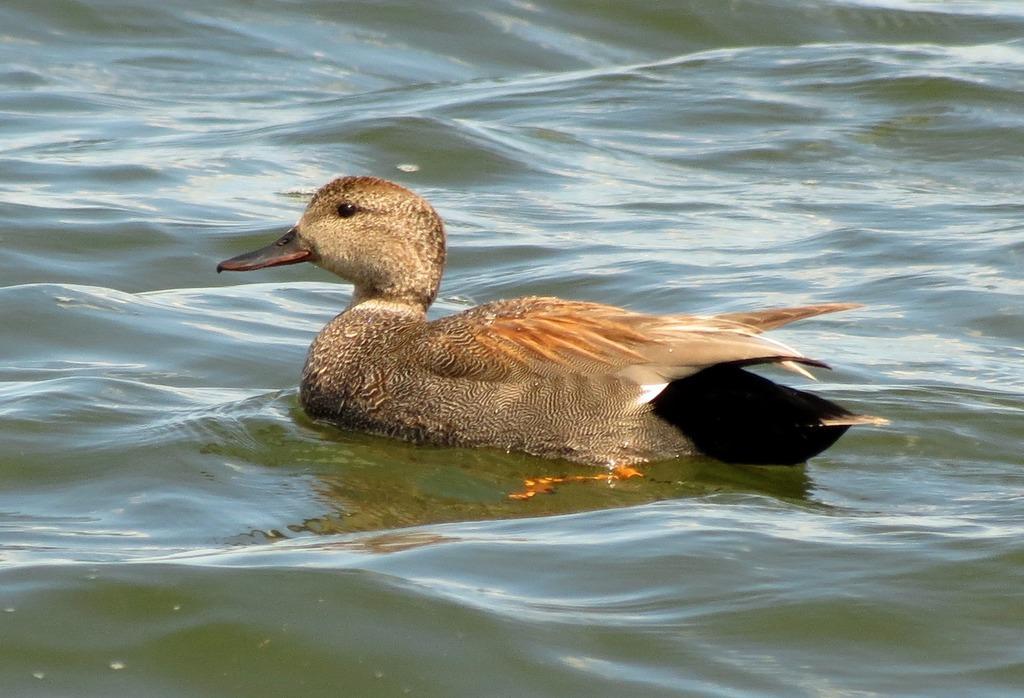How would you summarize this image in a sentence or two? In this picture there is a bird in the center of the image and there is water around the area of the image. 